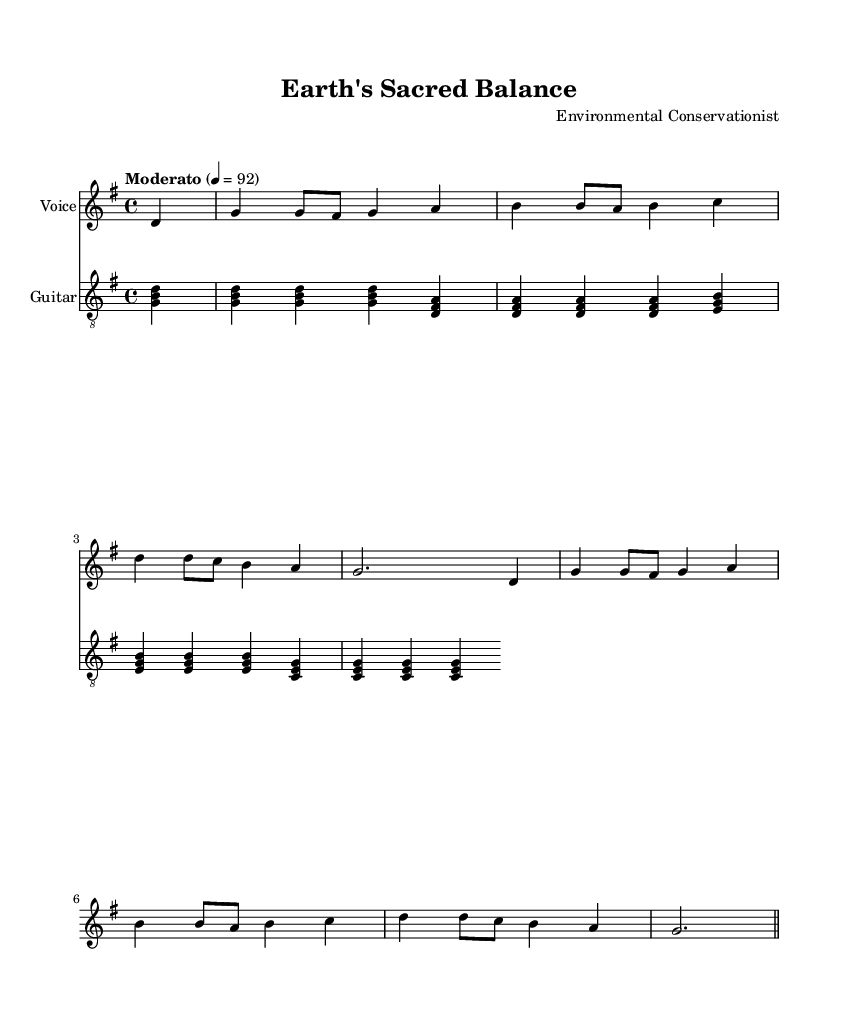What is the title of this piece? The title is stated in the header section of the sheet music under "title." It reads "Earth's Sacred Balance."
Answer: Earth's Sacred Balance What is the time signature of this music? The time signature is found at the beginning of the score, notated as 4/4.
Answer: 4/4 What is the key signature of this music? The key signature is indicated by the "#" symbol next to the "g" which means it is in the key of G major.
Answer: G major What is the tempo marking for this piece? The tempo marking is present in the global section and states "Moderato" with a metronome marking of 4 = 92.
Answer: Moderato How many verses are included in this song? This piece contains one verse as indicated by the structure of the lyrics section; it does not repeat multiple verses.
Answer: One What is the primary theme of the lyrics? The lyrics emphasize stewardship and conservation, focusing on caring for God's creation and the Earth, which is evident in the word choices throughout the verse and chorus.
Answer: Stewardship How does the chorus encourage action related to conservation? The chorus specifically mentions "Sustain the Earth" and "Conserve His gifts," which indicates a call to action for environmental stewardship and conservation efforts.
Answer: Conserve His gifts 